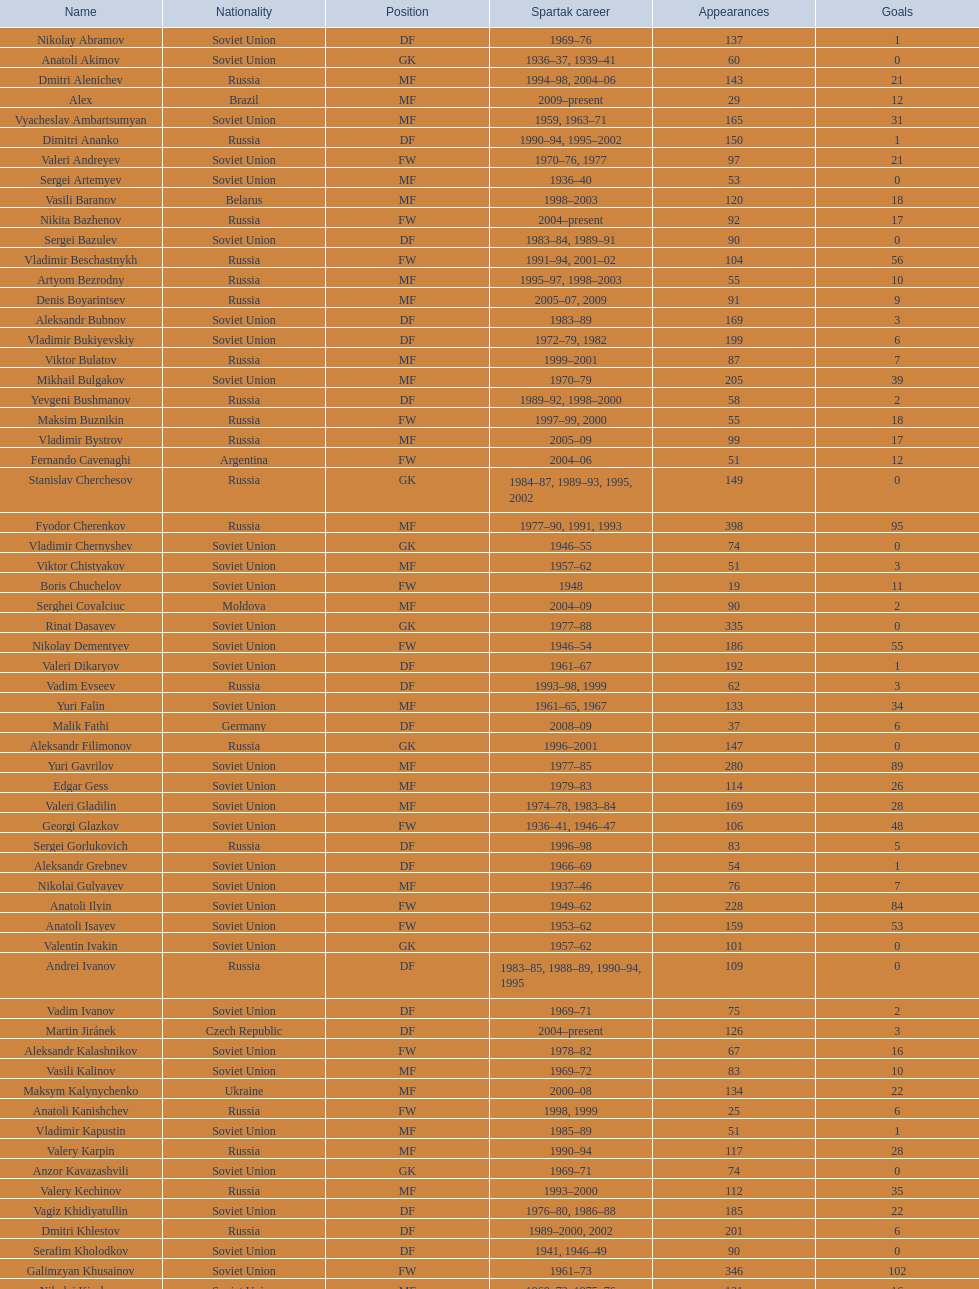Which two players have achieved over 15 goals? Dmitri Alenichev, Vyacheslav Ambartsumyan. 